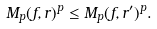<formula> <loc_0><loc_0><loc_500><loc_500>M _ { p } ( f , r ) ^ { p } \leq M _ { p } ( f , r ^ { \prime } ) ^ { p } .</formula> 